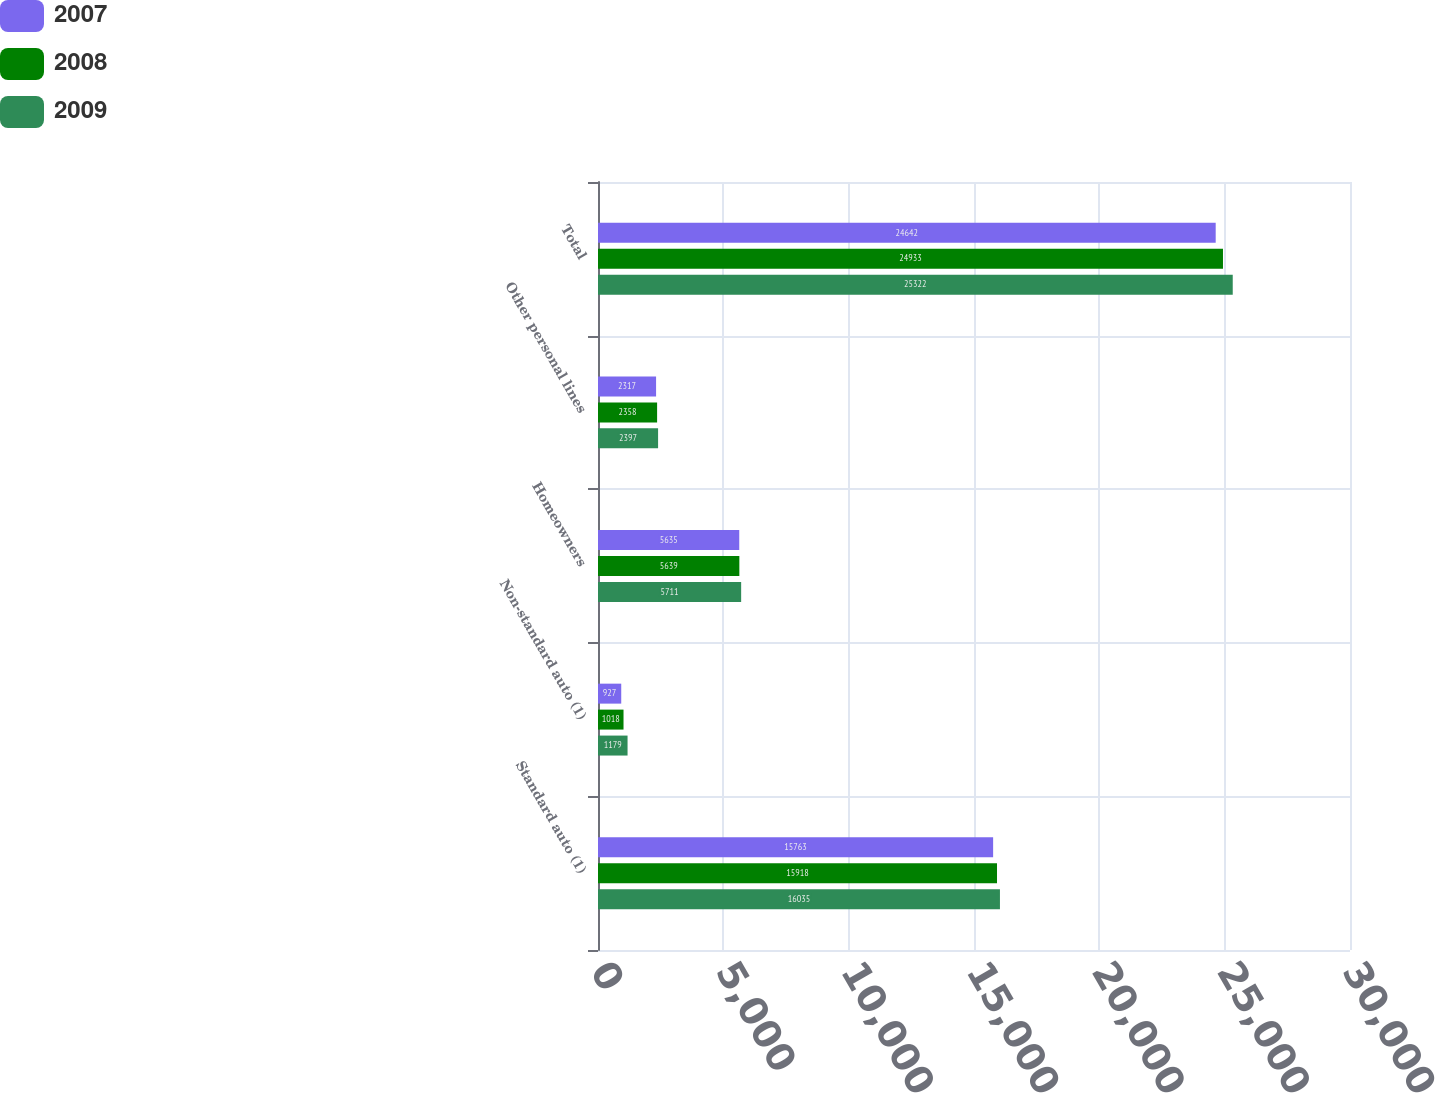Convert chart to OTSL. <chart><loc_0><loc_0><loc_500><loc_500><stacked_bar_chart><ecel><fcel>Standard auto (1)<fcel>Non-standard auto (1)<fcel>Homeowners<fcel>Other personal lines<fcel>Total<nl><fcel>2007<fcel>15763<fcel>927<fcel>5635<fcel>2317<fcel>24642<nl><fcel>2008<fcel>15918<fcel>1018<fcel>5639<fcel>2358<fcel>24933<nl><fcel>2009<fcel>16035<fcel>1179<fcel>5711<fcel>2397<fcel>25322<nl></chart> 